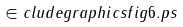Convert formula to latex. <formula><loc_0><loc_0><loc_500><loc_500>\in c l u d e g r a p h i c s { f i g 6 . p s }</formula> 